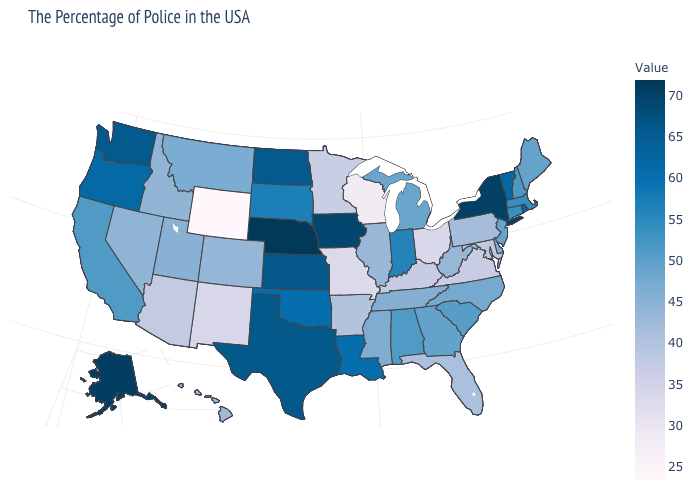Is the legend a continuous bar?
Give a very brief answer. Yes. Does Nebraska have the highest value in the USA?
Short answer required. Yes. Among the states that border Pennsylvania , does New York have the highest value?
Short answer required. Yes. Which states have the lowest value in the USA?
Quick response, please. Wyoming. Which states have the lowest value in the USA?
Concise answer only. Wyoming. Among the states that border Michigan , does Indiana have the highest value?
Quick response, please. Yes. 